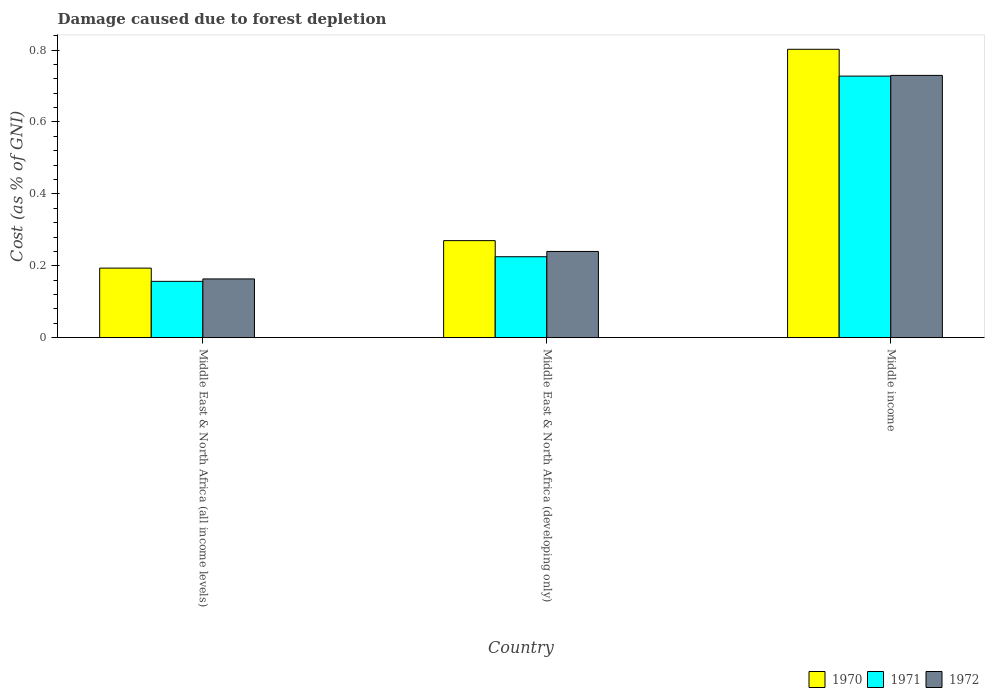How many different coloured bars are there?
Your response must be concise. 3. Are the number of bars per tick equal to the number of legend labels?
Offer a terse response. Yes. In how many cases, is the number of bars for a given country not equal to the number of legend labels?
Provide a short and direct response. 0. What is the cost of damage caused due to forest depletion in 1971 in Middle East & North Africa (developing only)?
Offer a terse response. 0.23. Across all countries, what is the maximum cost of damage caused due to forest depletion in 1972?
Offer a terse response. 0.73. Across all countries, what is the minimum cost of damage caused due to forest depletion in 1972?
Offer a very short reply. 0.16. In which country was the cost of damage caused due to forest depletion in 1972 maximum?
Provide a short and direct response. Middle income. In which country was the cost of damage caused due to forest depletion in 1970 minimum?
Your answer should be compact. Middle East & North Africa (all income levels). What is the total cost of damage caused due to forest depletion in 1970 in the graph?
Your answer should be very brief. 1.27. What is the difference between the cost of damage caused due to forest depletion in 1971 in Middle East & North Africa (all income levels) and that in Middle East & North Africa (developing only)?
Make the answer very short. -0.07. What is the difference between the cost of damage caused due to forest depletion in 1971 in Middle East & North Africa (all income levels) and the cost of damage caused due to forest depletion in 1970 in Middle income?
Keep it short and to the point. -0.65. What is the average cost of damage caused due to forest depletion in 1971 per country?
Keep it short and to the point. 0.37. What is the difference between the cost of damage caused due to forest depletion of/in 1970 and cost of damage caused due to forest depletion of/in 1972 in Middle income?
Give a very brief answer. 0.07. What is the ratio of the cost of damage caused due to forest depletion in 1970 in Middle East & North Africa (all income levels) to that in Middle East & North Africa (developing only)?
Make the answer very short. 0.72. Is the difference between the cost of damage caused due to forest depletion in 1970 in Middle East & North Africa (all income levels) and Middle East & North Africa (developing only) greater than the difference between the cost of damage caused due to forest depletion in 1972 in Middle East & North Africa (all income levels) and Middle East & North Africa (developing only)?
Keep it short and to the point. Yes. What is the difference between the highest and the second highest cost of damage caused due to forest depletion in 1971?
Ensure brevity in your answer.  0.57. What is the difference between the highest and the lowest cost of damage caused due to forest depletion in 1970?
Give a very brief answer. 0.61. What does the 2nd bar from the left in Middle East & North Africa (all income levels) represents?
Your response must be concise. 1971. What does the 1st bar from the right in Middle East & North Africa (developing only) represents?
Offer a terse response. 1972. Are all the bars in the graph horizontal?
Provide a succinct answer. No. Are the values on the major ticks of Y-axis written in scientific E-notation?
Make the answer very short. No. Where does the legend appear in the graph?
Your answer should be very brief. Bottom right. What is the title of the graph?
Offer a very short reply. Damage caused due to forest depletion. Does "1992" appear as one of the legend labels in the graph?
Offer a terse response. No. What is the label or title of the Y-axis?
Your answer should be very brief. Cost (as % of GNI). What is the Cost (as % of GNI) of 1970 in Middle East & North Africa (all income levels)?
Make the answer very short. 0.19. What is the Cost (as % of GNI) in 1971 in Middle East & North Africa (all income levels)?
Offer a terse response. 0.16. What is the Cost (as % of GNI) in 1972 in Middle East & North Africa (all income levels)?
Your answer should be very brief. 0.16. What is the Cost (as % of GNI) of 1970 in Middle East & North Africa (developing only)?
Provide a succinct answer. 0.27. What is the Cost (as % of GNI) of 1971 in Middle East & North Africa (developing only)?
Give a very brief answer. 0.23. What is the Cost (as % of GNI) of 1972 in Middle East & North Africa (developing only)?
Ensure brevity in your answer.  0.24. What is the Cost (as % of GNI) of 1970 in Middle income?
Your answer should be very brief. 0.8. What is the Cost (as % of GNI) of 1971 in Middle income?
Offer a very short reply. 0.73. What is the Cost (as % of GNI) in 1972 in Middle income?
Keep it short and to the point. 0.73. Across all countries, what is the maximum Cost (as % of GNI) in 1970?
Keep it short and to the point. 0.8. Across all countries, what is the maximum Cost (as % of GNI) in 1971?
Offer a terse response. 0.73. Across all countries, what is the maximum Cost (as % of GNI) in 1972?
Make the answer very short. 0.73. Across all countries, what is the minimum Cost (as % of GNI) in 1970?
Provide a succinct answer. 0.19. Across all countries, what is the minimum Cost (as % of GNI) of 1971?
Provide a short and direct response. 0.16. Across all countries, what is the minimum Cost (as % of GNI) in 1972?
Ensure brevity in your answer.  0.16. What is the total Cost (as % of GNI) in 1970 in the graph?
Give a very brief answer. 1.27. What is the total Cost (as % of GNI) in 1971 in the graph?
Provide a short and direct response. 1.11. What is the total Cost (as % of GNI) in 1972 in the graph?
Offer a terse response. 1.13. What is the difference between the Cost (as % of GNI) of 1970 in Middle East & North Africa (all income levels) and that in Middle East & North Africa (developing only)?
Keep it short and to the point. -0.08. What is the difference between the Cost (as % of GNI) in 1971 in Middle East & North Africa (all income levels) and that in Middle East & North Africa (developing only)?
Your answer should be very brief. -0.07. What is the difference between the Cost (as % of GNI) of 1972 in Middle East & North Africa (all income levels) and that in Middle East & North Africa (developing only)?
Provide a succinct answer. -0.08. What is the difference between the Cost (as % of GNI) in 1970 in Middle East & North Africa (all income levels) and that in Middle income?
Your answer should be compact. -0.61. What is the difference between the Cost (as % of GNI) in 1971 in Middle East & North Africa (all income levels) and that in Middle income?
Provide a succinct answer. -0.57. What is the difference between the Cost (as % of GNI) of 1972 in Middle East & North Africa (all income levels) and that in Middle income?
Keep it short and to the point. -0.57. What is the difference between the Cost (as % of GNI) of 1970 in Middle East & North Africa (developing only) and that in Middle income?
Give a very brief answer. -0.53. What is the difference between the Cost (as % of GNI) of 1971 in Middle East & North Africa (developing only) and that in Middle income?
Make the answer very short. -0.5. What is the difference between the Cost (as % of GNI) in 1972 in Middle East & North Africa (developing only) and that in Middle income?
Provide a short and direct response. -0.49. What is the difference between the Cost (as % of GNI) of 1970 in Middle East & North Africa (all income levels) and the Cost (as % of GNI) of 1971 in Middle East & North Africa (developing only)?
Provide a succinct answer. -0.03. What is the difference between the Cost (as % of GNI) of 1970 in Middle East & North Africa (all income levels) and the Cost (as % of GNI) of 1972 in Middle East & North Africa (developing only)?
Your answer should be compact. -0.05. What is the difference between the Cost (as % of GNI) of 1971 in Middle East & North Africa (all income levels) and the Cost (as % of GNI) of 1972 in Middle East & North Africa (developing only)?
Your answer should be very brief. -0.08. What is the difference between the Cost (as % of GNI) in 1970 in Middle East & North Africa (all income levels) and the Cost (as % of GNI) in 1971 in Middle income?
Give a very brief answer. -0.53. What is the difference between the Cost (as % of GNI) in 1970 in Middle East & North Africa (all income levels) and the Cost (as % of GNI) in 1972 in Middle income?
Offer a terse response. -0.54. What is the difference between the Cost (as % of GNI) of 1971 in Middle East & North Africa (all income levels) and the Cost (as % of GNI) of 1972 in Middle income?
Ensure brevity in your answer.  -0.57. What is the difference between the Cost (as % of GNI) of 1970 in Middle East & North Africa (developing only) and the Cost (as % of GNI) of 1971 in Middle income?
Your answer should be compact. -0.46. What is the difference between the Cost (as % of GNI) of 1970 in Middle East & North Africa (developing only) and the Cost (as % of GNI) of 1972 in Middle income?
Provide a short and direct response. -0.46. What is the difference between the Cost (as % of GNI) of 1971 in Middle East & North Africa (developing only) and the Cost (as % of GNI) of 1972 in Middle income?
Your answer should be compact. -0.5. What is the average Cost (as % of GNI) in 1970 per country?
Make the answer very short. 0.42. What is the average Cost (as % of GNI) of 1971 per country?
Provide a short and direct response. 0.37. What is the average Cost (as % of GNI) in 1972 per country?
Your answer should be compact. 0.38. What is the difference between the Cost (as % of GNI) of 1970 and Cost (as % of GNI) of 1971 in Middle East & North Africa (all income levels)?
Offer a terse response. 0.04. What is the difference between the Cost (as % of GNI) of 1970 and Cost (as % of GNI) of 1972 in Middle East & North Africa (all income levels)?
Ensure brevity in your answer.  0.03. What is the difference between the Cost (as % of GNI) in 1971 and Cost (as % of GNI) in 1972 in Middle East & North Africa (all income levels)?
Provide a succinct answer. -0.01. What is the difference between the Cost (as % of GNI) in 1970 and Cost (as % of GNI) in 1971 in Middle East & North Africa (developing only)?
Your response must be concise. 0.04. What is the difference between the Cost (as % of GNI) in 1970 and Cost (as % of GNI) in 1972 in Middle East & North Africa (developing only)?
Give a very brief answer. 0.03. What is the difference between the Cost (as % of GNI) of 1971 and Cost (as % of GNI) of 1972 in Middle East & North Africa (developing only)?
Ensure brevity in your answer.  -0.01. What is the difference between the Cost (as % of GNI) of 1970 and Cost (as % of GNI) of 1971 in Middle income?
Ensure brevity in your answer.  0.07. What is the difference between the Cost (as % of GNI) of 1970 and Cost (as % of GNI) of 1972 in Middle income?
Your response must be concise. 0.07. What is the difference between the Cost (as % of GNI) in 1971 and Cost (as % of GNI) in 1972 in Middle income?
Your answer should be very brief. -0. What is the ratio of the Cost (as % of GNI) of 1970 in Middle East & North Africa (all income levels) to that in Middle East & North Africa (developing only)?
Keep it short and to the point. 0.72. What is the ratio of the Cost (as % of GNI) in 1971 in Middle East & North Africa (all income levels) to that in Middle East & North Africa (developing only)?
Your answer should be very brief. 0.7. What is the ratio of the Cost (as % of GNI) in 1972 in Middle East & North Africa (all income levels) to that in Middle East & North Africa (developing only)?
Keep it short and to the point. 0.68. What is the ratio of the Cost (as % of GNI) of 1970 in Middle East & North Africa (all income levels) to that in Middle income?
Provide a succinct answer. 0.24. What is the ratio of the Cost (as % of GNI) in 1971 in Middle East & North Africa (all income levels) to that in Middle income?
Your response must be concise. 0.22. What is the ratio of the Cost (as % of GNI) in 1972 in Middle East & North Africa (all income levels) to that in Middle income?
Ensure brevity in your answer.  0.22. What is the ratio of the Cost (as % of GNI) in 1970 in Middle East & North Africa (developing only) to that in Middle income?
Provide a short and direct response. 0.34. What is the ratio of the Cost (as % of GNI) of 1971 in Middle East & North Africa (developing only) to that in Middle income?
Give a very brief answer. 0.31. What is the ratio of the Cost (as % of GNI) in 1972 in Middle East & North Africa (developing only) to that in Middle income?
Offer a terse response. 0.33. What is the difference between the highest and the second highest Cost (as % of GNI) of 1970?
Offer a terse response. 0.53. What is the difference between the highest and the second highest Cost (as % of GNI) in 1971?
Provide a succinct answer. 0.5. What is the difference between the highest and the second highest Cost (as % of GNI) in 1972?
Ensure brevity in your answer.  0.49. What is the difference between the highest and the lowest Cost (as % of GNI) of 1970?
Give a very brief answer. 0.61. What is the difference between the highest and the lowest Cost (as % of GNI) in 1971?
Offer a very short reply. 0.57. What is the difference between the highest and the lowest Cost (as % of GNI) of 1972?
Provide a succinct answer. 0.57. 